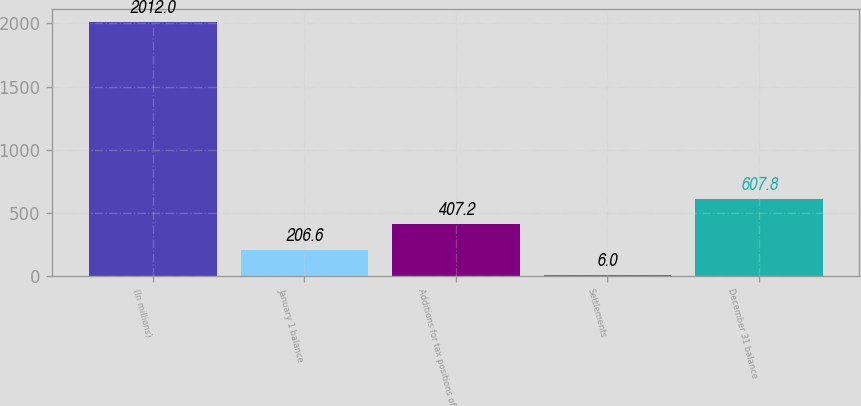Convert chart. <chart><loc_0><loc_0><loc_500><loc_500><bar_chart><fcel>(In millions)<fcel>January 1 balance<fcel>Additions for tax positions of<fcel>Settlements<fcel>December 31 balance<nl><fcel>2012<fcel>206.6<fcel>407.2<fcel>6<fcel>607.8<nl></chart> 